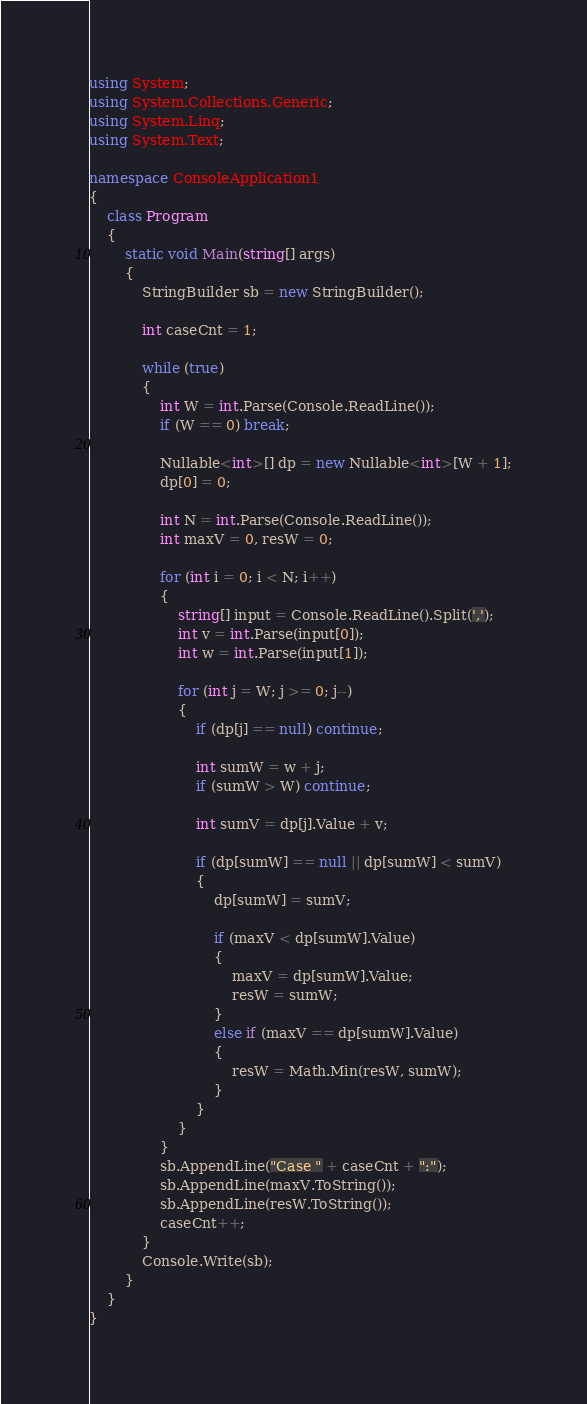Convert code to text. <code><loc_0><loc_0><loc_500><loc_500><_C#_>using System;
using System.Collections.Generic;
using System.Linq;
using System.Text;

namespace ConsoleApplication1
{
    class Program
    {
        static void Main(string[] args)
        {
            StringBuilder sb = new StringBuilder();

            int caseCnt = 1;

            while (true)
            {
                int W = int.Parse(Console.ReadLine());
                if (W == 0) break;

                Nullable<int>[] dp = new Nullable<int>[W + 1];
                dp[0] = 0;

                int N = int.Parse(Console.ReadLine());
                int maxV = 0, resW = 0;

                for (int i = 0; i < N; i++)
                {
                    string[] input = Console.ReadLine().Split(',');
                    int v = int.Parse(input[0]);
                    int w = int.Parse(input[1]);

                    for (int j = W; j >= 0; j--)
                    {
                        if (dp[j] == null) continue;

                        int sumW = w + j;
                        if (sumW > W) continue;

                        int sumV = dp[j].Value + v;

                        if (dp[sumW] == null || dp[sumW] < sumV)
                        {
                            dp[sumW] = sumV;

                            if (maxV < dp[sumW].Value)
                            {
                                maxV = dp[sumW].Value;
                                resW = sumW;
                            }
                            else if (maxV == dp[sumW].Value)
                            {
                                resW = Math.Min(resW, sumW);
                            }
                        }
                    }
                }
                sb.AppendLine("Case " + caseCnt + ":");
                sb.AppendLine(maxV.ToString());
                sb.AppendLine(resW.ToString());
                caseCnt++;
            }
            Console.Write(sb);
        }
    }
}</code> 